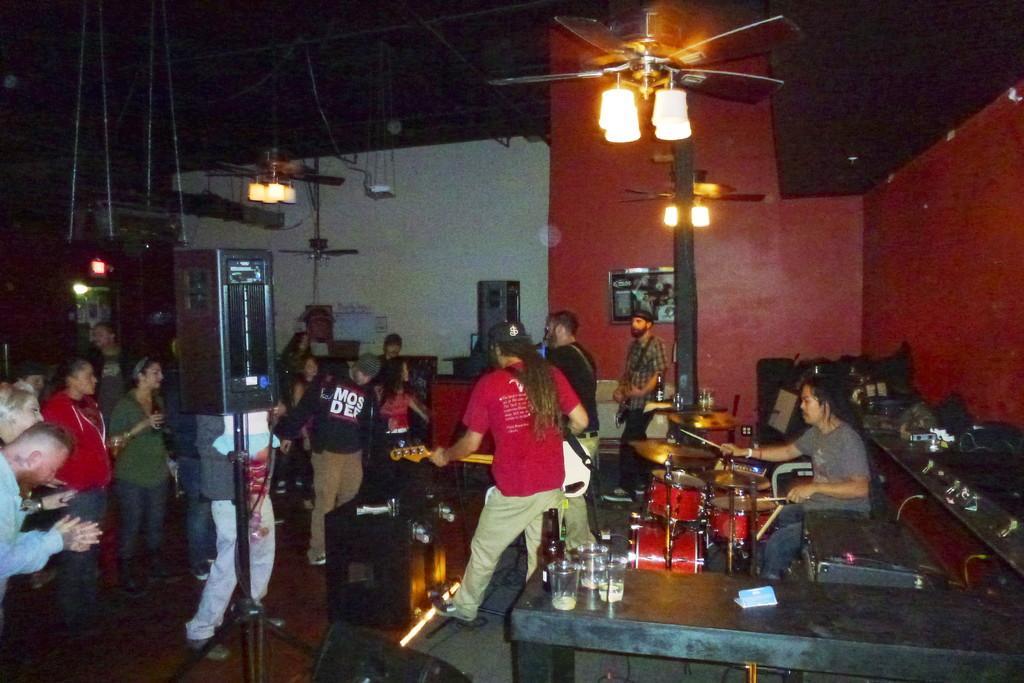Could you give a brief overview of what you see in this image? This image is clicked inside a room. To the left there are people standing. To the left there are musicians playing musical instruments. There is a man sitting on the chair and playing drums. There are lamps to the fans. In the foreground there is a table. There are glasses on the table. In the background there is a wall. 